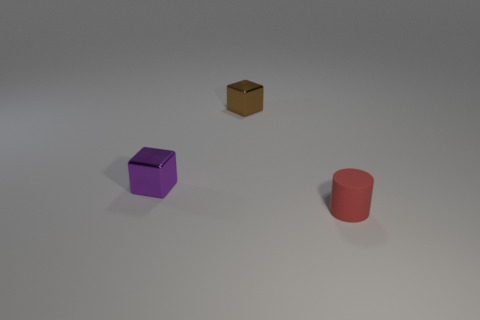Is there any other thing that has the same material as the red thing?
Your answer should be very brief. No. What is the color of the other thing that is made of the same material as the small brown thing?
Ensure brevity in your answer.  Purple. What is the size of the thing that is behind the tiny red cylinder and on the right side of the tiny purple metal object?
Your answer should be very brief. Small. Are there fewer small metallic objects that are on the right side of the cylinder than tiny brown metallic cubes in front of the tiny purple shiny cube?
Ensure brevity in your answer.  No. Is the material of the tiny purple thing that is in front of the tiny brown cube the same as the tiny block that is behind the tiny purple metal object?
Make the answer very short. Yes. There is a thing that is both right of the small purple metal cube and behind the small red object; what shape is it?
Provide a short and direct response. Cube. The small block that is behind the tiny cube that is in front of the brown metal cube is made of what material?
Ensure brevity in your answer.  Metal. Are there more small cylinders than metallic cubes?
Give a very brief answer. No. What is the material of the purple thing that is the same size as the cylinder?
Offer a very short reply. Metal. Is the small red object made of the same material as the small brown thing?
Offer a terse response. No. 